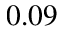Convert formula to latex. <formula><loc_0><loc_0><loc_500><loc_500>0 . 0 9</formula> 